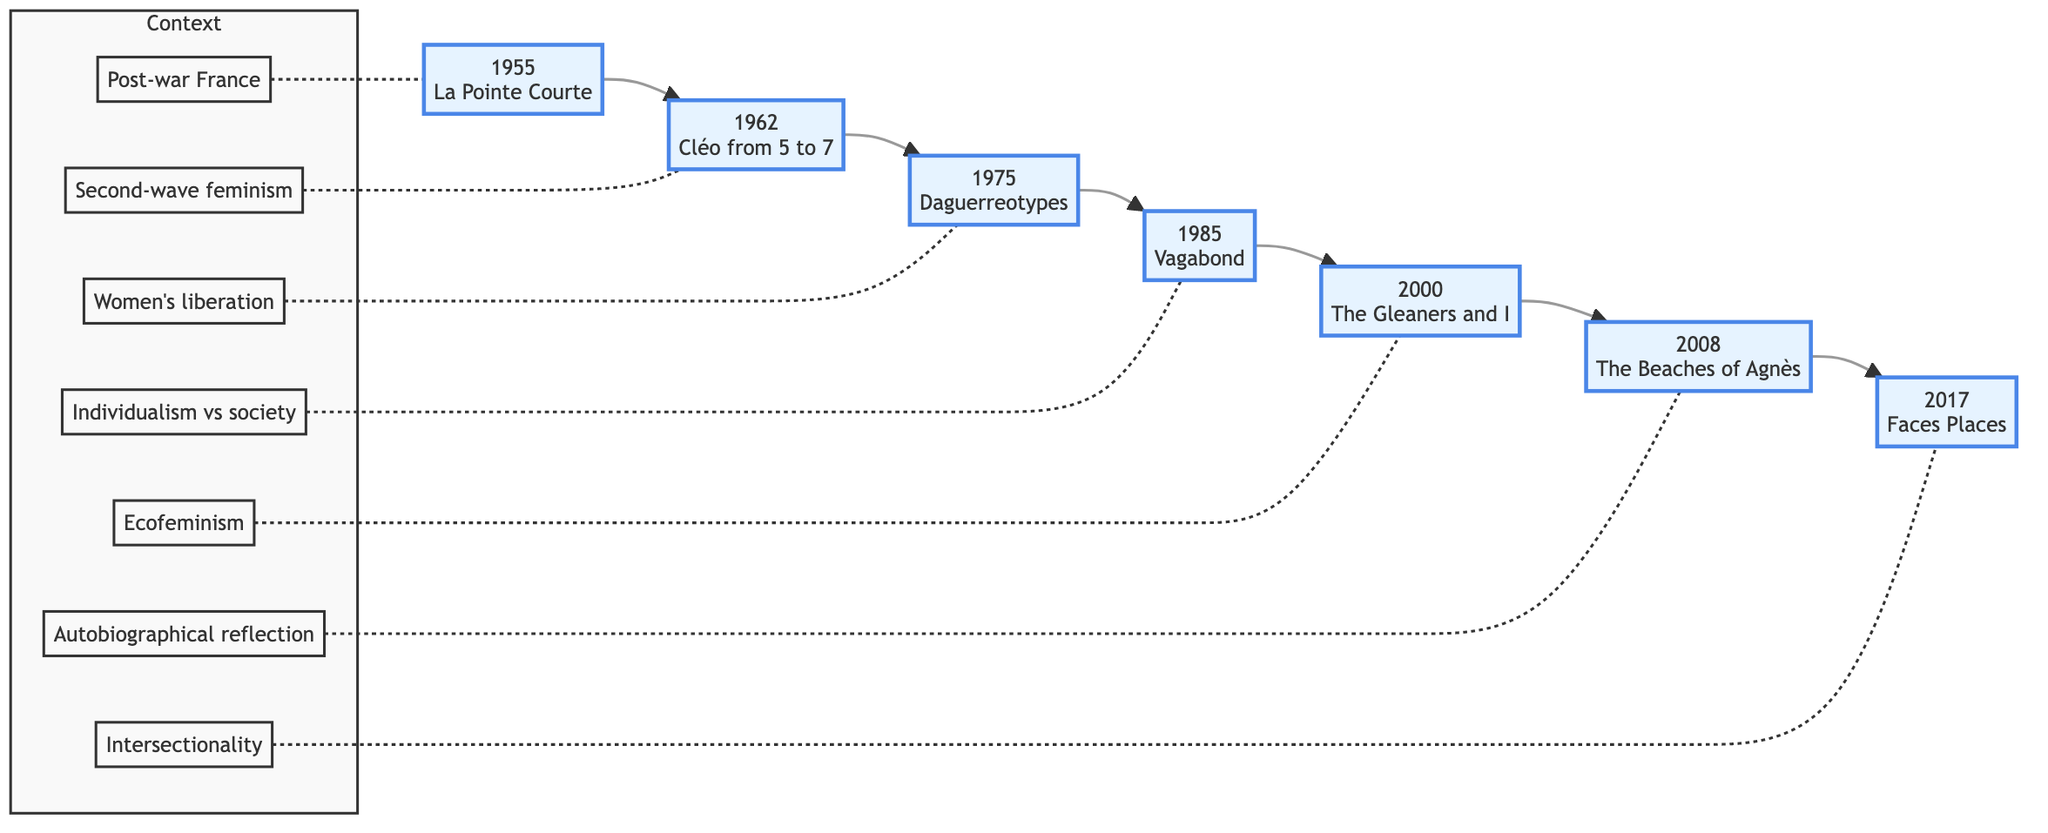What is the first film listed in the flowchart? The first film in the flowchart is found at the starting node, which is "1955 - La Pointe Courte".
Answer: 1955 - La Pointe Courte How many films are presented in the flowchart? By counting the nodes from the beginning to the end of the flowchart, there are a total of seven films presented.
Answer: 7 What feminist theme is explored in "1985 - Vagabond"? Looking at the description of "1985 - Vagabond", it focuses on societal perceptions of a woman living outside societal norms, indicating individualism versus societal expectations.
Answer: Individualism vs societal expectations Which film corresponds with the context of "Second-wave feminism"? In the flowchart, the film "1962 - Cléo from 5 to 7" is indicated to match the context of second-wave feminism.
Answer: 1962 - Cléo from 5 to 7 What is the relationship between "2000 - The Gleaners and I" and ecofeminism? Analyzing the context associated with "2000 - The Gleaners and I", it shows that this film explores themes of wastage and survival from a primarily female perspective, linking it to ecofeminism.
Answer: Ecofeminism Which film discusses the daily lives of women in a Parisian neighborhood? Inspecting the description of "1975 - Daguerreotypes", it reveals that the film documents women in a Parisian neighborhood, highlighting their struggles and daily lives.
Answer: 1975 - Daguerreotypes What is the last film shown in the flowchart? The flowchart concludes with "2017 - Faces Places", as it is the last node in the sequence, indicating the chronological progression of feminist themes.
Answer: 2017 - Faces Places Which film's context refers to a reflective examination of Agnès Varda's career? By reviewing the context labelled for "2008 - The Beaches of Agnès", it specifically refers to a self-reflective examination of Varda's career and her feminist perspectives.
Answer: 2008 - The Beaches of Agnès What is the common theme among the films listed in the flowchart? The common theme presents the chronological development of feminist themes, as each film addresses different aspects of women's roles and issues through time.
Answer: Feminist themes 